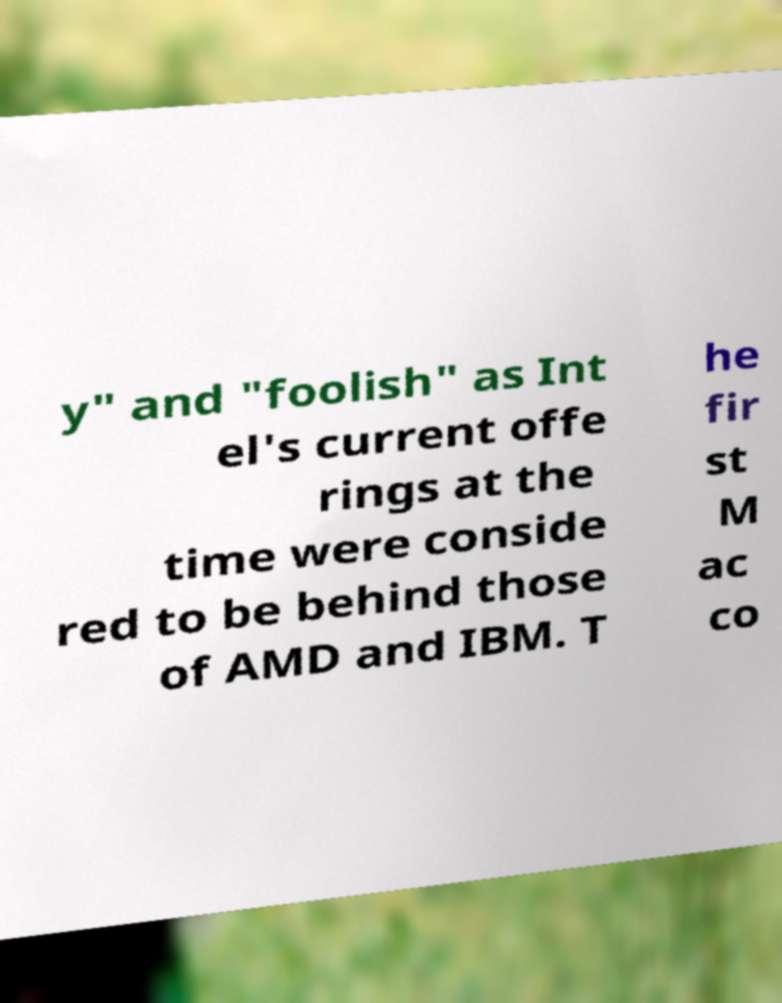What messages or text are displayed in this image? I need them in a readable, typed format. y" and "foolish" as Int el's current offe rings at the time were conside red to be behind those of AMD and IBM. T he fir st M ac co 